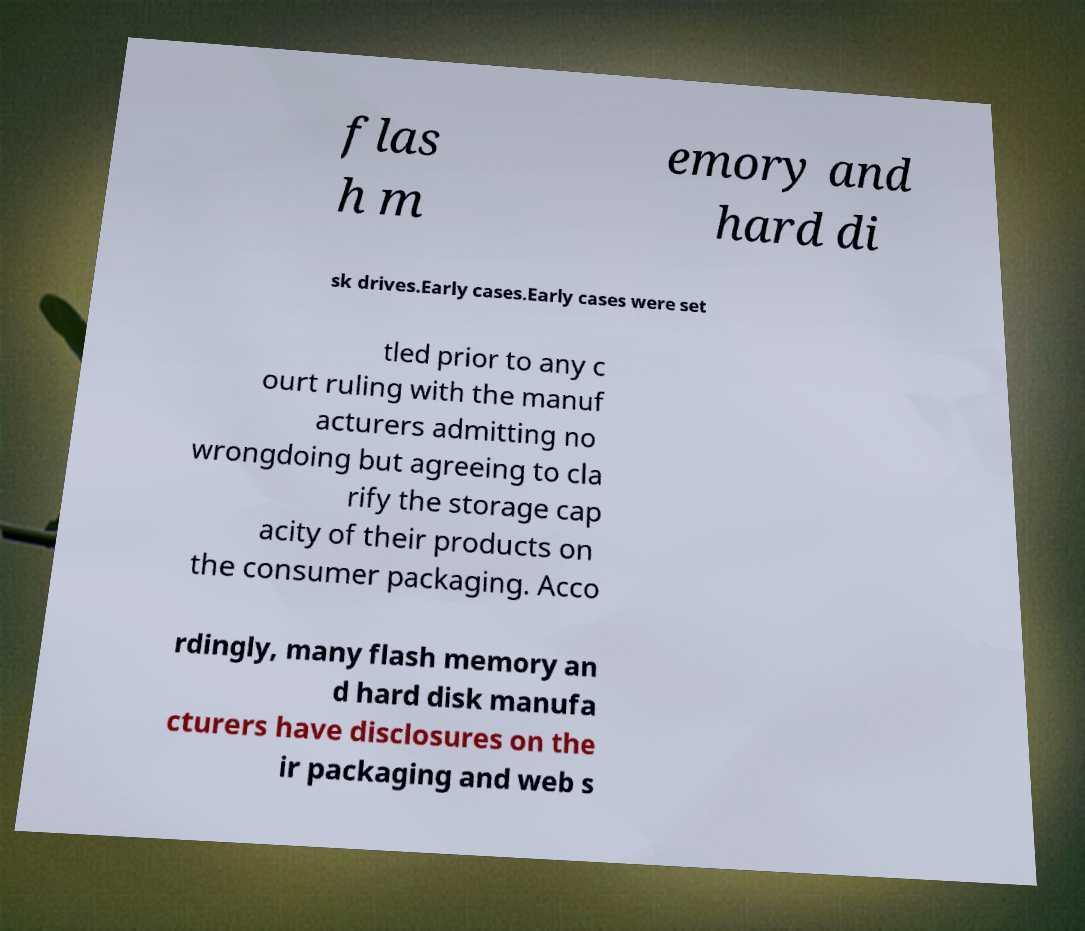For documentation purposes, I need the text within this image transcribed. Could you provide that? flas h m emory and hard di sk drives.Early cases.Early cases were set tled prior to any c ourt ruling with the manuf acturers admitting no wrongdoing but agreeing to cla rify the storage cap acity of their products on the consumer packaging. Acco rdingly, many flash memory an d hard disk manufa cturers have disclosures on the ir packaging and web s 